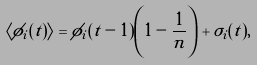<formula> <loc_0><loc_0><loc_500><loc_500>\langle \phi _ { i } ( t ) \rangle = \phi _ { i } ( t - 1 ) \left ( 1 - \frac { 1 } { n } \right ) + \sigma _ { i } ( t ) ,</formula> 